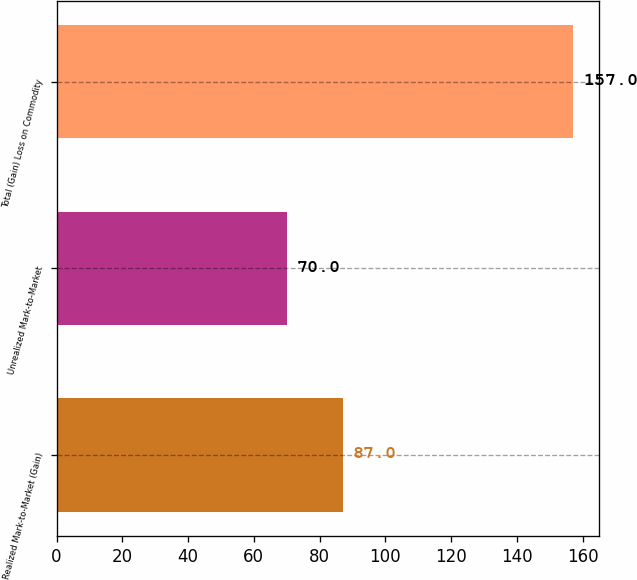Convert chart to OTSL. <chart><loc_0><loc_0><loc_500><loc_500><bar_chart><fcel>Realized Mark-to-Market (Gain)<fcel>Unrealized Mark-to-Market<fcel>Total (Gain) Loss on Commodity<nl><fcel>87<fcel>70<fcel>157<nl></chart> 